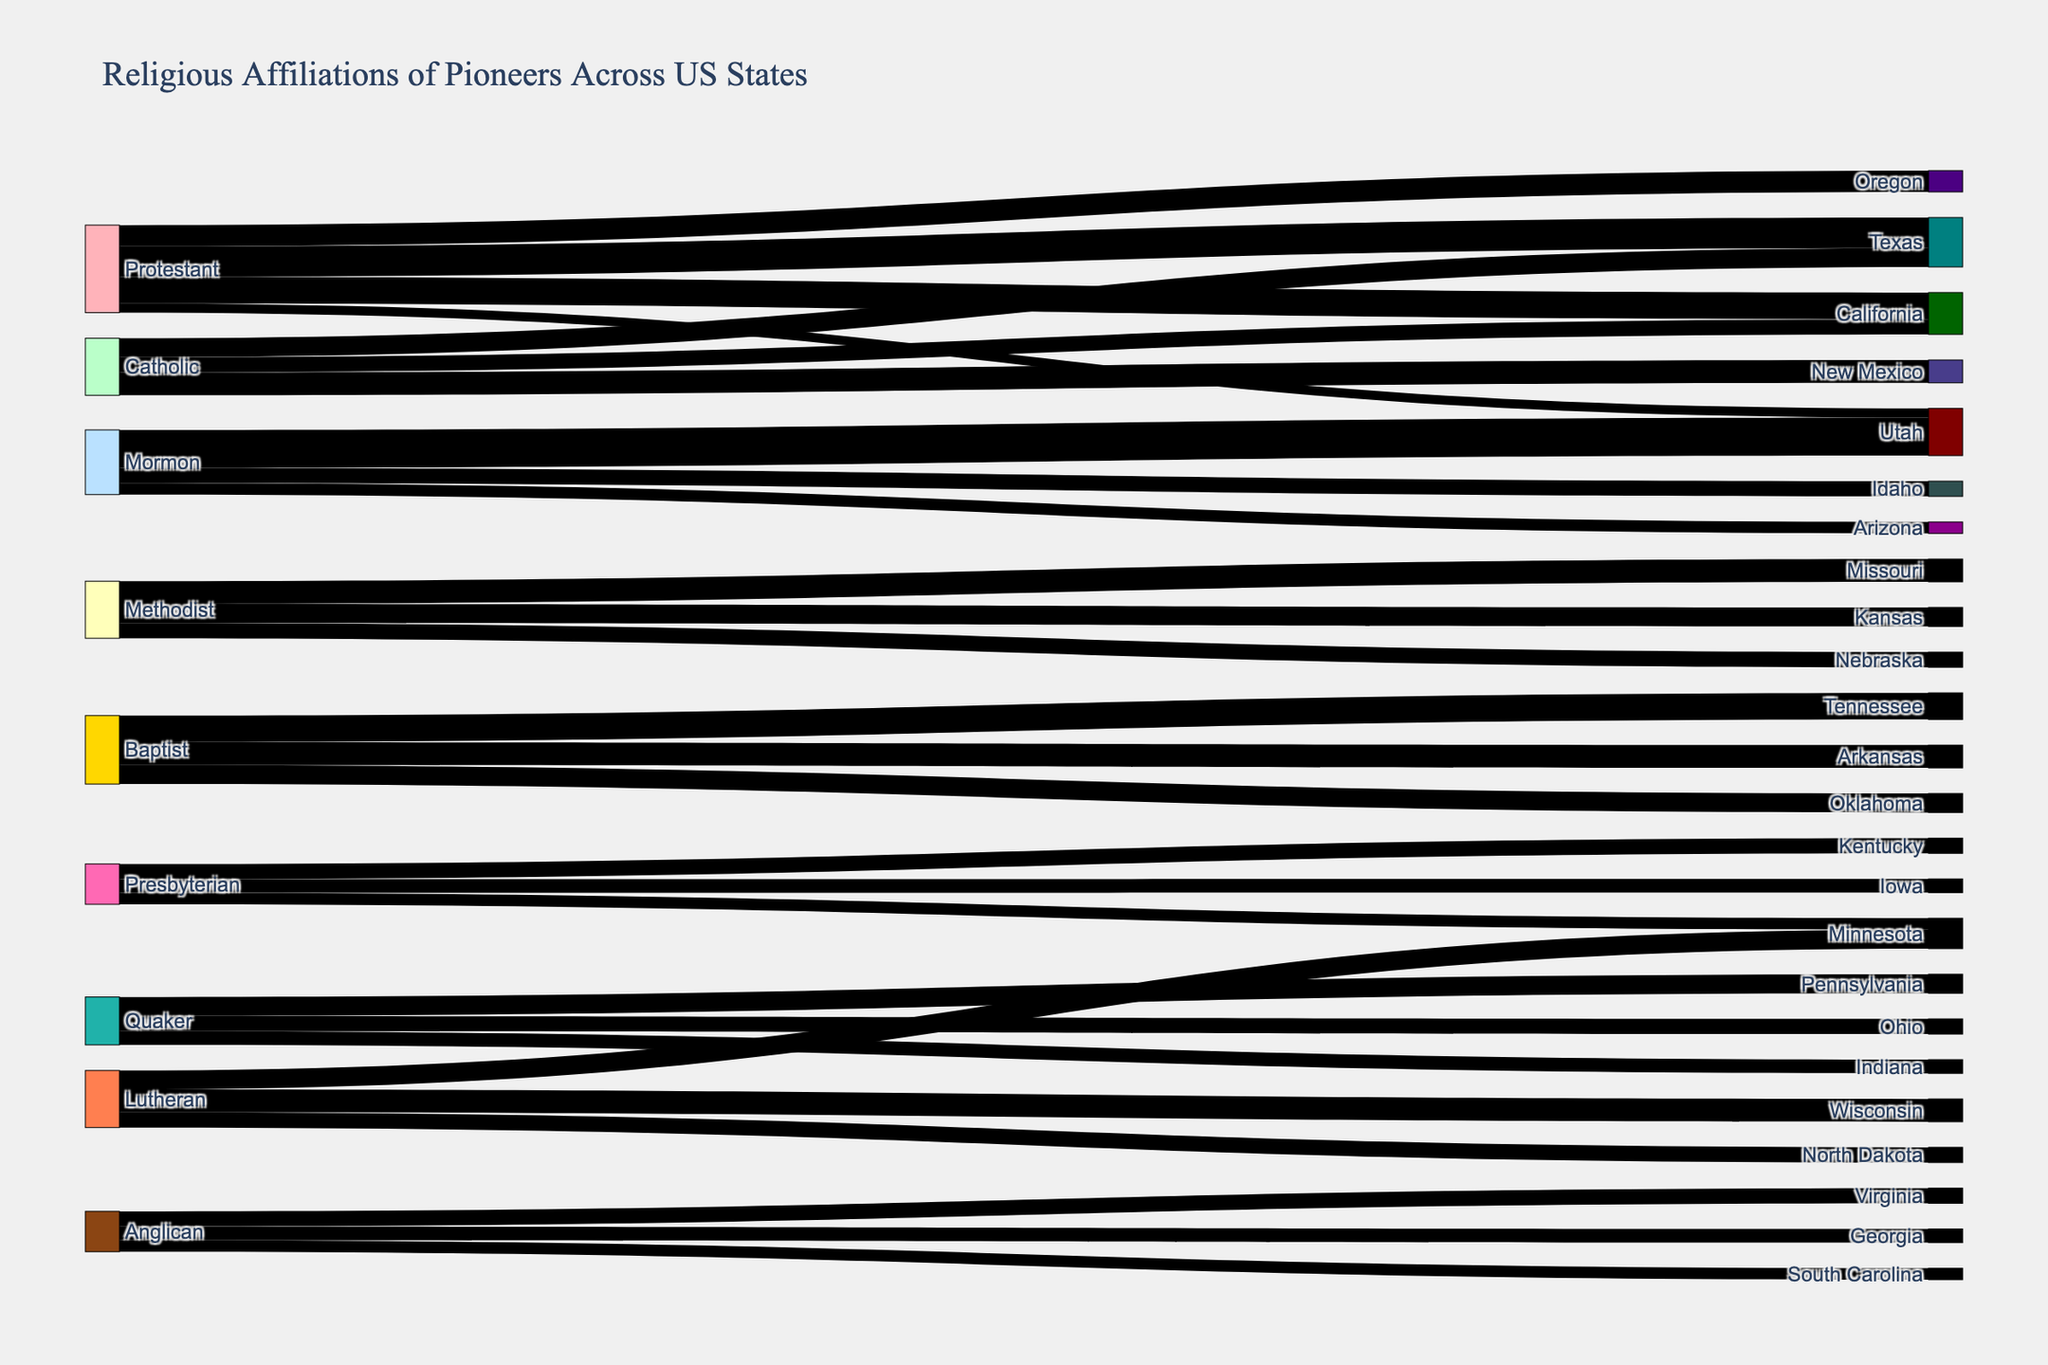Which religious affiliation had the highest number of pioneers going to any state? Mormon pioneers going to Utah had the highest number at 5,000. By looking at the link thickness, the largest value represents Mormon pioneers moving to Utah.
Answer: Mormon Which states received Protestant pioneers, and what was the total number? Protestants moved to California (3,500), Oregon (2,800), Utah (1,200), and Texas (4,000). Adding these values gives a total of 3,500 + 2,800 + 1,200 + 4,000 = 11,500.
Answer: California, Oregon, Utah, Texas; 11,500 How many states did Quaker pioneers migrate to, and what are those states? Quaker pioneers moved to three states: Pennsylvania, Ohio, and Indiana. This can be observed by looking at the connections from 'Quaker' to different states.
Answer: Three; Pennsylvania, Ohio, Indiana Compare the number of Methodist pioneers in Missouri and Kansas. Which state received more, and by how much? Missouri received 3,000 and Kansas received 2,500 Methodist pioneers. Missouri received more by a difference of 3,000 - 2,500 = 500.
Answer: Missouri; 500 Identify the states where multiple religious affiliations converged, and specify which affiliations. Texas had Protestants (4,000) and Catholics (2,500). California had Protestants (3,500) and Catholics (2,000). By looking at states with multiple incoming links shaded differently, we can determine the corresponding religions.
Answer: Texas: Protestant, Catholic; California: Protestant, Catholic What is the combined total of Lutheran settlers in the three states they moved to? Lutherans moved to Wisconsin (3,000), Minnesota (2,500), and North Dakota (2,000). Adding the values gives 3,000 + 2,500 + 2,000 = 7,500.
Answer: 7,500 Which state received the fewest Mormon pioneers, and how many did it receive? Arizona received the fewest Mormon pioneers at 1,500. This is identified by comparing the numbers of Mormons going to Utah, Idaho, and Arizona.
Answer: Arizona; 1,500 Which state received the highest number of pioneers according to the diagram, and which religious affiliation was it associated with? Utah received the highest number of pioneers, specifically Mormon pioneers with a total of 5,000. This is identified by the thickest link leading to a state.
Answer: Utah; Mormon 